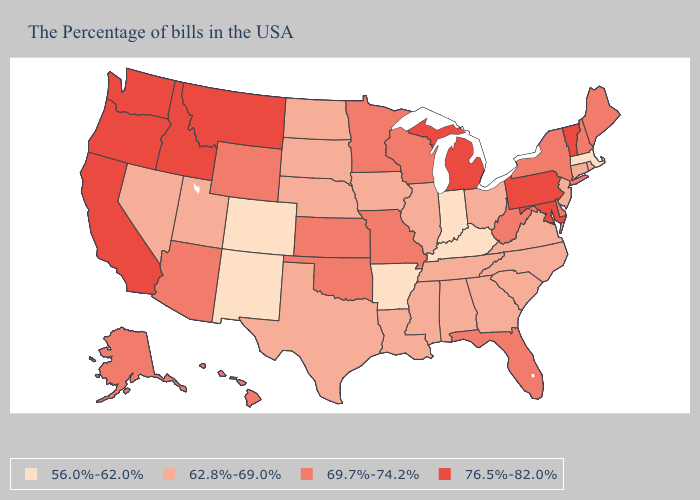Name the states that have a value in the range 62.8%-69.0%?
Be succinct. Rhode Island, Connecticut, New Jersey, Virginia, North Carolina, South Carolina, Ohio, Georgia, Alabama, Tennessee, Illinois, Mississippi, Louisiana, Iowa, Nebraska, Texas, South Dakota, North Dakota, Utah, Nevada. Does Oregon have the highest value in the USA?
Quick response, please. Yes. Which states have the highest value in the USA?
Give a very brief answer. Vermont, Maryland, Pennsylvania, Michigan, Montana, Idaho, California, Washington, Oregon. Which states have the lowest value in the MidWest?
Answer briefly. Indiana. Name the states that have a value in the range 56.0%-62.0%?
Answer briefly. Massachusetts, Kentucky, Indiana, Arkansas, Colorado, New Mexico. What is the value of Hawaii?
Short answer required. 69.7%-74.2%. Name the states that have a value in the range 62.8%-69.0%?
Be succinct. Rhode Island, Connecticut, New Jersey, Virginia, North Carolina, South Carolina, Ohio, Georgia, Alabama, Tennessee, Illinois, Mississippi, Louisiana, Iowa, Nebraska, Texas, South Dakota, North Dakota, Utah, Nevada. What is the highest value in the USA?
Write a very short answer. 76.5%-82.0%. What is the value of Nevada?
Write a very short answer. 62.8%-69.0%. What is the value of Michigan?
Keep it brief. 76.5%-82.0%. Among the states that border Missouri , which have the lowest value?
Give a very brief answer. Kentucky, Arkansas. Does the map have missing data?
Keep it brief. No. Does Massachusetts have the lowest value in the USA?
Write a very short answer. Yes. What is the value of Vermont?
Answer briefly. 76.5%-82.0%. Among the states that border Missouri , does Tennessee have the highest value?
Concise answer only. No. 